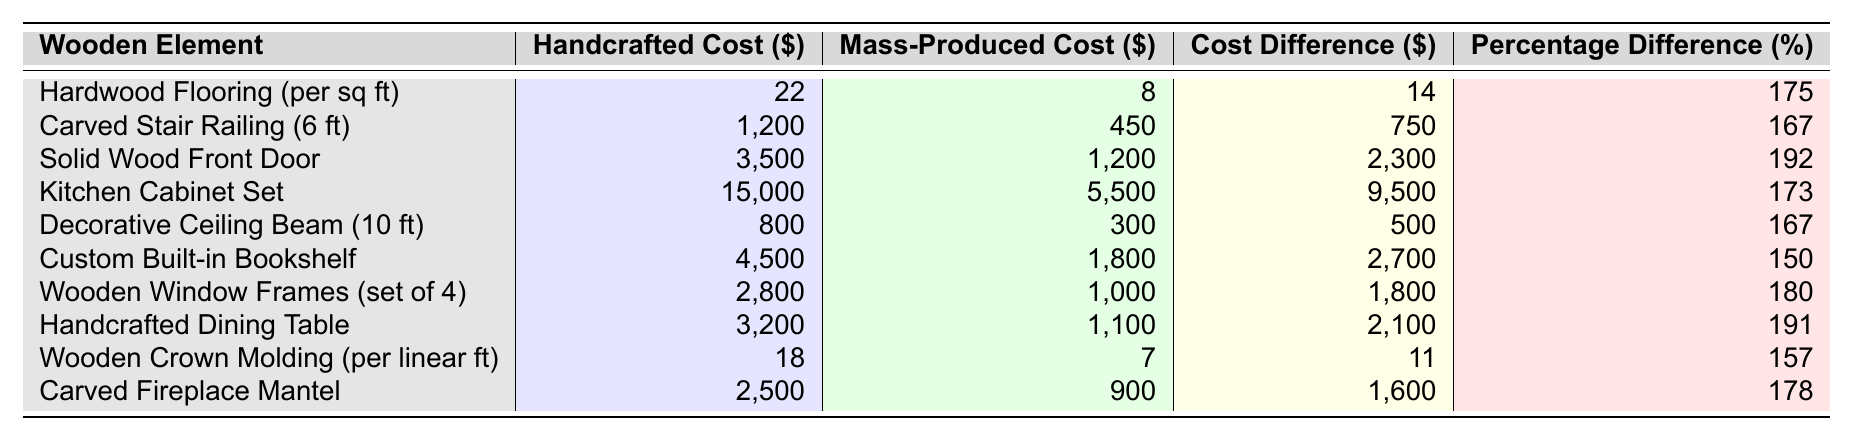What is the cost difference between handcrafted and mass-produced hardwood flooring per square foot? The handcrafted cost of hardwood flooring is $22, and the mass-produced cost is $8. The difference is calculated as $22 - $8 = $14.
Answer: 14 Which wooden element has the highest cost difference between handcrafted and mass-produced forms? The solid wood front door has the highest cost difference of $2300 (handcrafted $3500 - mass-produced $1200).
Answer: Solid wood front door What percentage difference in cost is associated with the carved staircase railing? The percentage difference for the carved stair railing is given as 167%. This is calculated from the cost difference of $750 relative to the mass-produced cost of $450: (750/450)*100 = 166.67%, which rounds to 167%.
Answer: 167% Is the handcrafted dining table cheaper than the handcrafted solid wood front door? The handcrafted dining table costs $3200, while the handcrafted solid wood front door costs $3500. Since $3200 is less than $3500, the statement is true.
Answer: Yes What is the average cost difference for all the wooden elements listed in the table? The cost differences are 14, 750, 2300, 9500, 500, 2700, 1800, 2100, 11, and 1600. Summing these values gives 14500. There are 10 elements, so the average is calculated as 14500 / 10 = 1450.
Answer: 1450 If I wanted to replace all the wooden window frames with handcrafted ones, how much more would it cost compared to mass-produced ones? The handcrafted cost for wooden window frames is $2800, and the mass-produced cost is $1000. The additional cost to switch is $2800 - $1000 = $1800.
Answer: 1800 Which wooden element has the lowest percentage difference between handcrafted and mass-produced prices? The custom built-in bookshelf has the lowest percentage difference at 150%, which is noted in the table and represents the least discrepancy in pricing between handcrafted and mass-produced options.
Answer: Custom built-in bookshelf If I sum the costs of the handcrafted elements, what total should I expect? The costs for handcrafted items are 22, 1200, 3500, 15000, 800, 4500, 2800, 3200, 18, and 2500. Adding these values gives a total of 22 + 1200 + 3500 + 15000 + 800 + 4500 + 2800 + 3200 + 18 + 2500 = 25842.
Answer: 25842 Are decorative ceiling beams more than twice as expensive when handcrafted compared to mass-produced? The handcrafted cost for decorative ceiling beams is $800, while the mass-produced cost is $300. Twice the mass-produced cost is $600 (300 * 2). Since $800 is greater than $600, the statement is true.
Answer: Yes If you were to buy one of each element, what would be the total cost of all handcrafted items? The total cost for handcrafted items would be 22 + 1200 + 3500 + 15000 + 800 + 4500 + 2800 + 3200 + 18 + 2500 = 25842.
Answer: 25842 